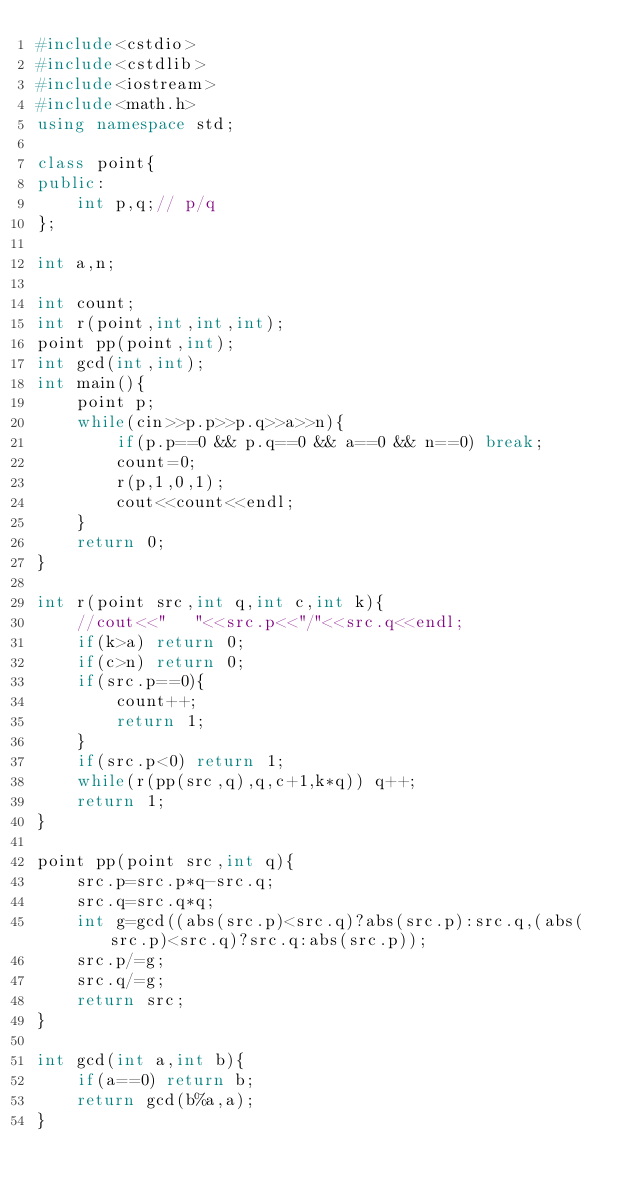<code> <loc_0><loc_0><loc_500><loc_500><_C++_>#include<cstdio>
#include<cstdlib>
#include<iostream>
#include<math.h>
using namespace std;

class point{
public:
	int p,q;// p/q
};

int a,n;

int count;
int r(point,int,int,int);
point pp(point,int);
int gcd(int,int);
int main(){
	point p;
	while(cin>>p.p>>p.q>>a>>n){
		if(p.p==0 && p.q==0 && a==0 && n==0) break;
		count=0;
		r(p,1,0,1);
		cout<<count<<endl;
	}
	return 0;
}

int r(point src,int q,int c,int k){
	//cout<<"   "<<src.p<<"/"<<src.q<<endl;
	if(k>a) return 0;
	if(c>n) return 0;
	if(src.p==0){
		count++;
		return 1;
	}
	if(src.p<0) return 1;
	while(r(pp(src,q),q,c+1,k*q)) q++;
	return 1;
}

point pp(point src,int q){
	src.p=src.p*q-src.q;
	src.q=src.q*q;
	int g=gcd((abs(src.p)<src.q)?abs(src.p):src.q,(abs(src.p)<src.q)?src.q:abs(src.p));
	src.p/=g;
	src.q/=g;
	return src;
}

int gcd(int a,int b){
	if(a==0) return b;
	return gcd(b%a,a);
}</code> 